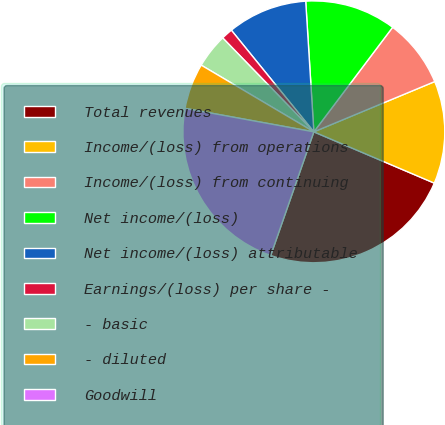Convert chart to OTSL. <chart><loc_0><loc_0><loc_500><loc_500><pie_chart><fcel>Total revenues<fcel>Income/(loss) from operations<fcel>Income/(loss) from continuing<fcel>Net income/(loss)<fcel>Net income/(loss) attributable<fcel>Earnings/(loss) per share -<fcel>- basic<fcel>- diluted<fcel>Goodwill<nl><fcel>23.94%<fcel>12.68%<fcel>8.45%<fcel>11.27%<fcel>9.86%<fcel>1.41%<fcel>4.23%<fcel>5.64%<fcel>22.53%<nl></chart> 